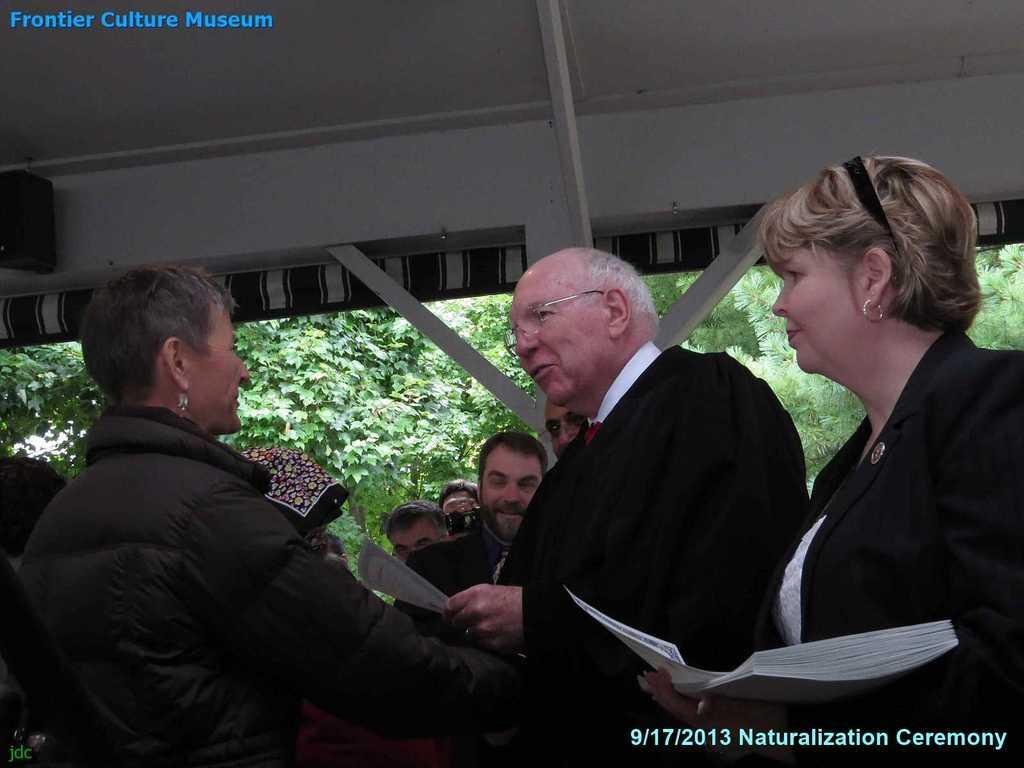How would you summarize this image in a sentence or two? In this image there are group of persons standing and smiling. In the front there is a woman standing and holding papers in her hand and in the center there is a man standing and smiling and holding a paper in his hand. In the background there are trees and on the top there is a shelter which is white in colour and there is some text written on the image. 